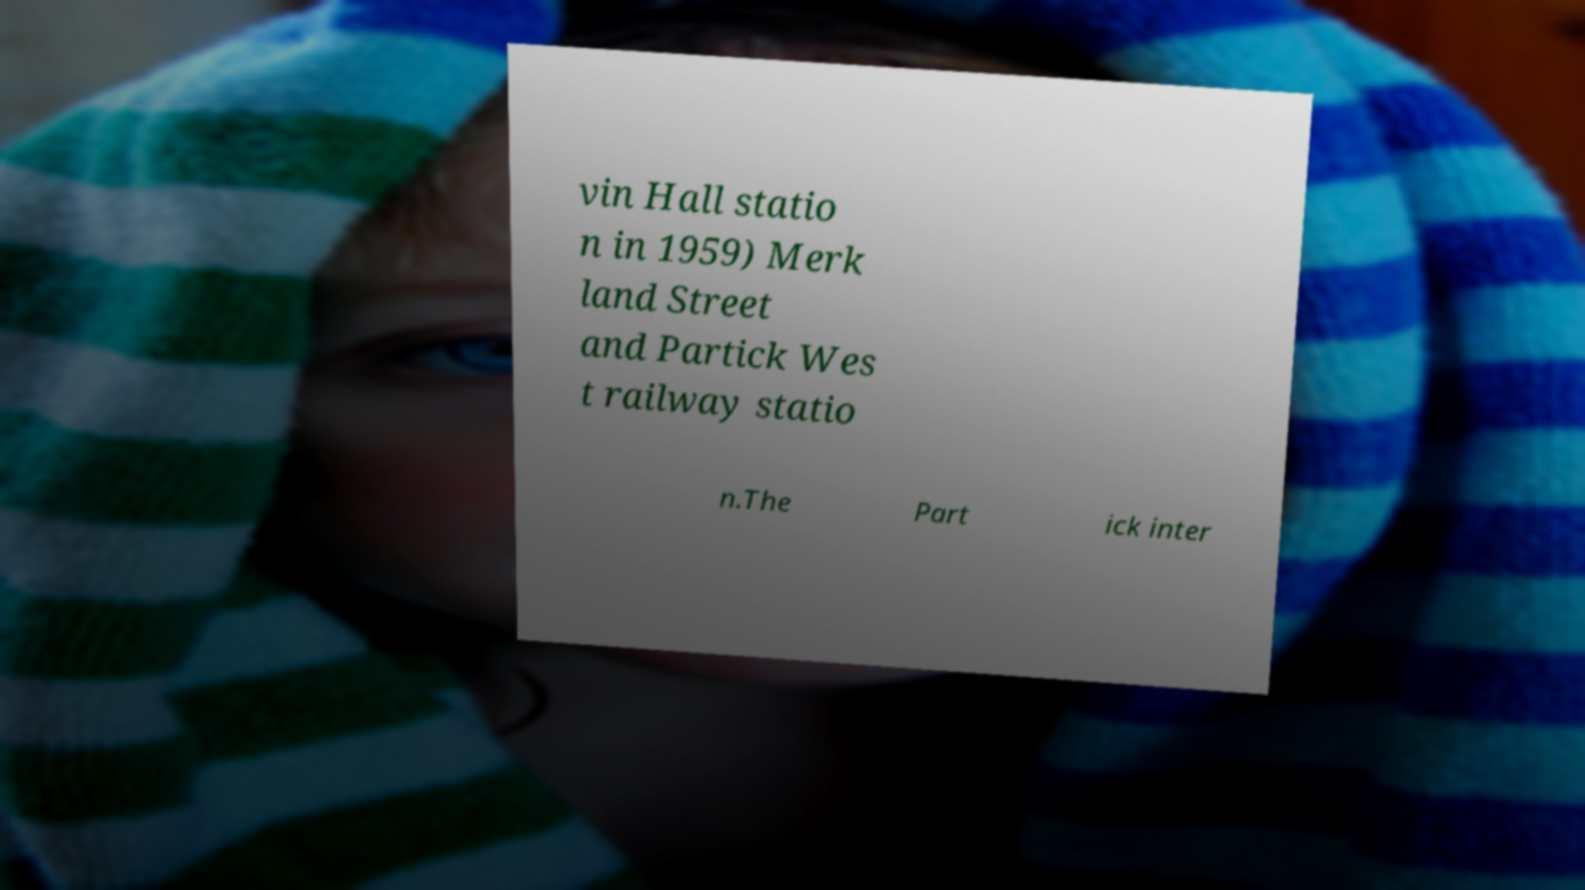What messages or text are displayed in this image? I need them in a readable, typed format. vin Hall statio n in 1959) Merk land Street and Partick Wes t railway statio n.The Part ick inter 